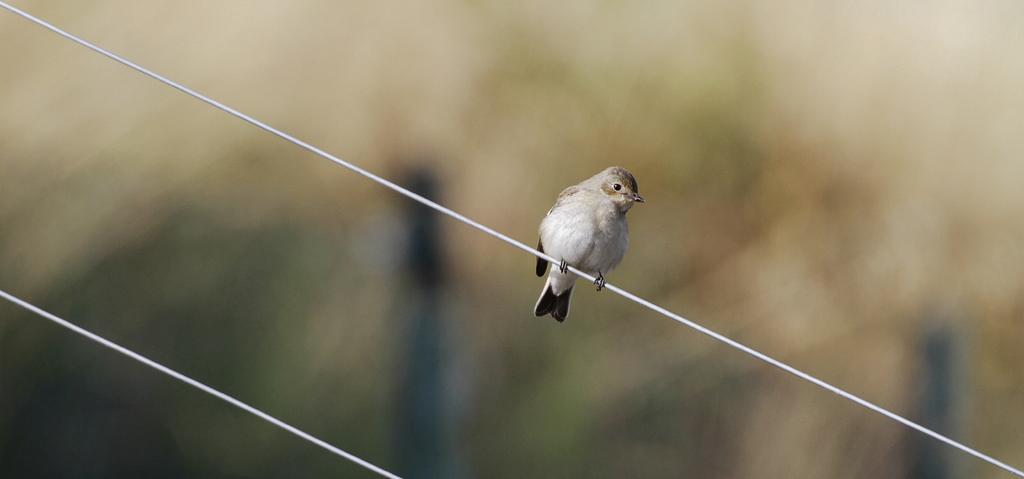In one or two sentences, can you explain what this image depicts? In this image we can see a bird on the wire. The background of the image is blurred. 